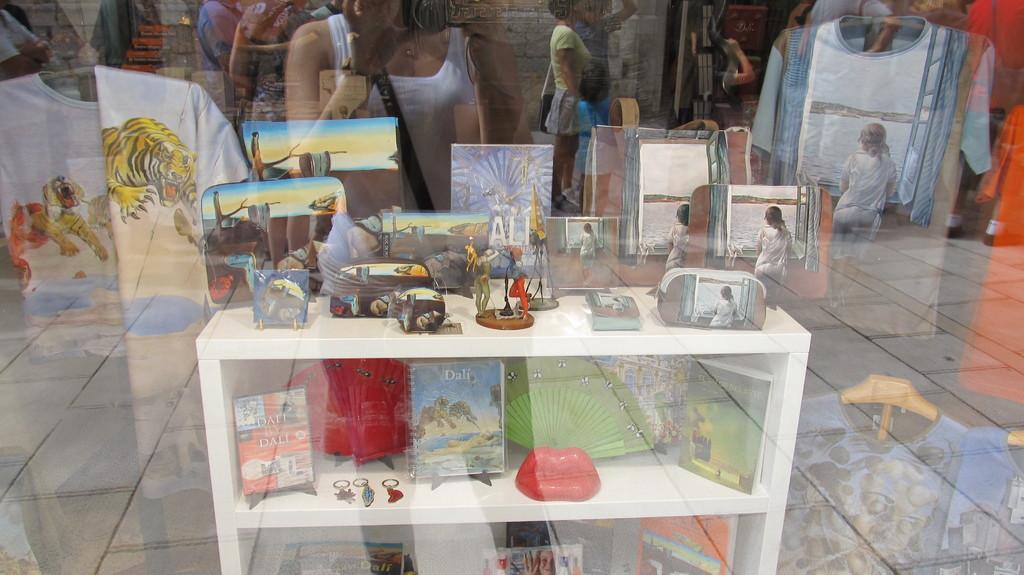In one or two sentences, can you explain what this image depicts? In this image in the foreground there is a glass and through the glass we could see reflection of some people, clothes, and one cupboard. And in that cupboard there are some books and some objects, and on the cupboard there are some toys and some objects. 